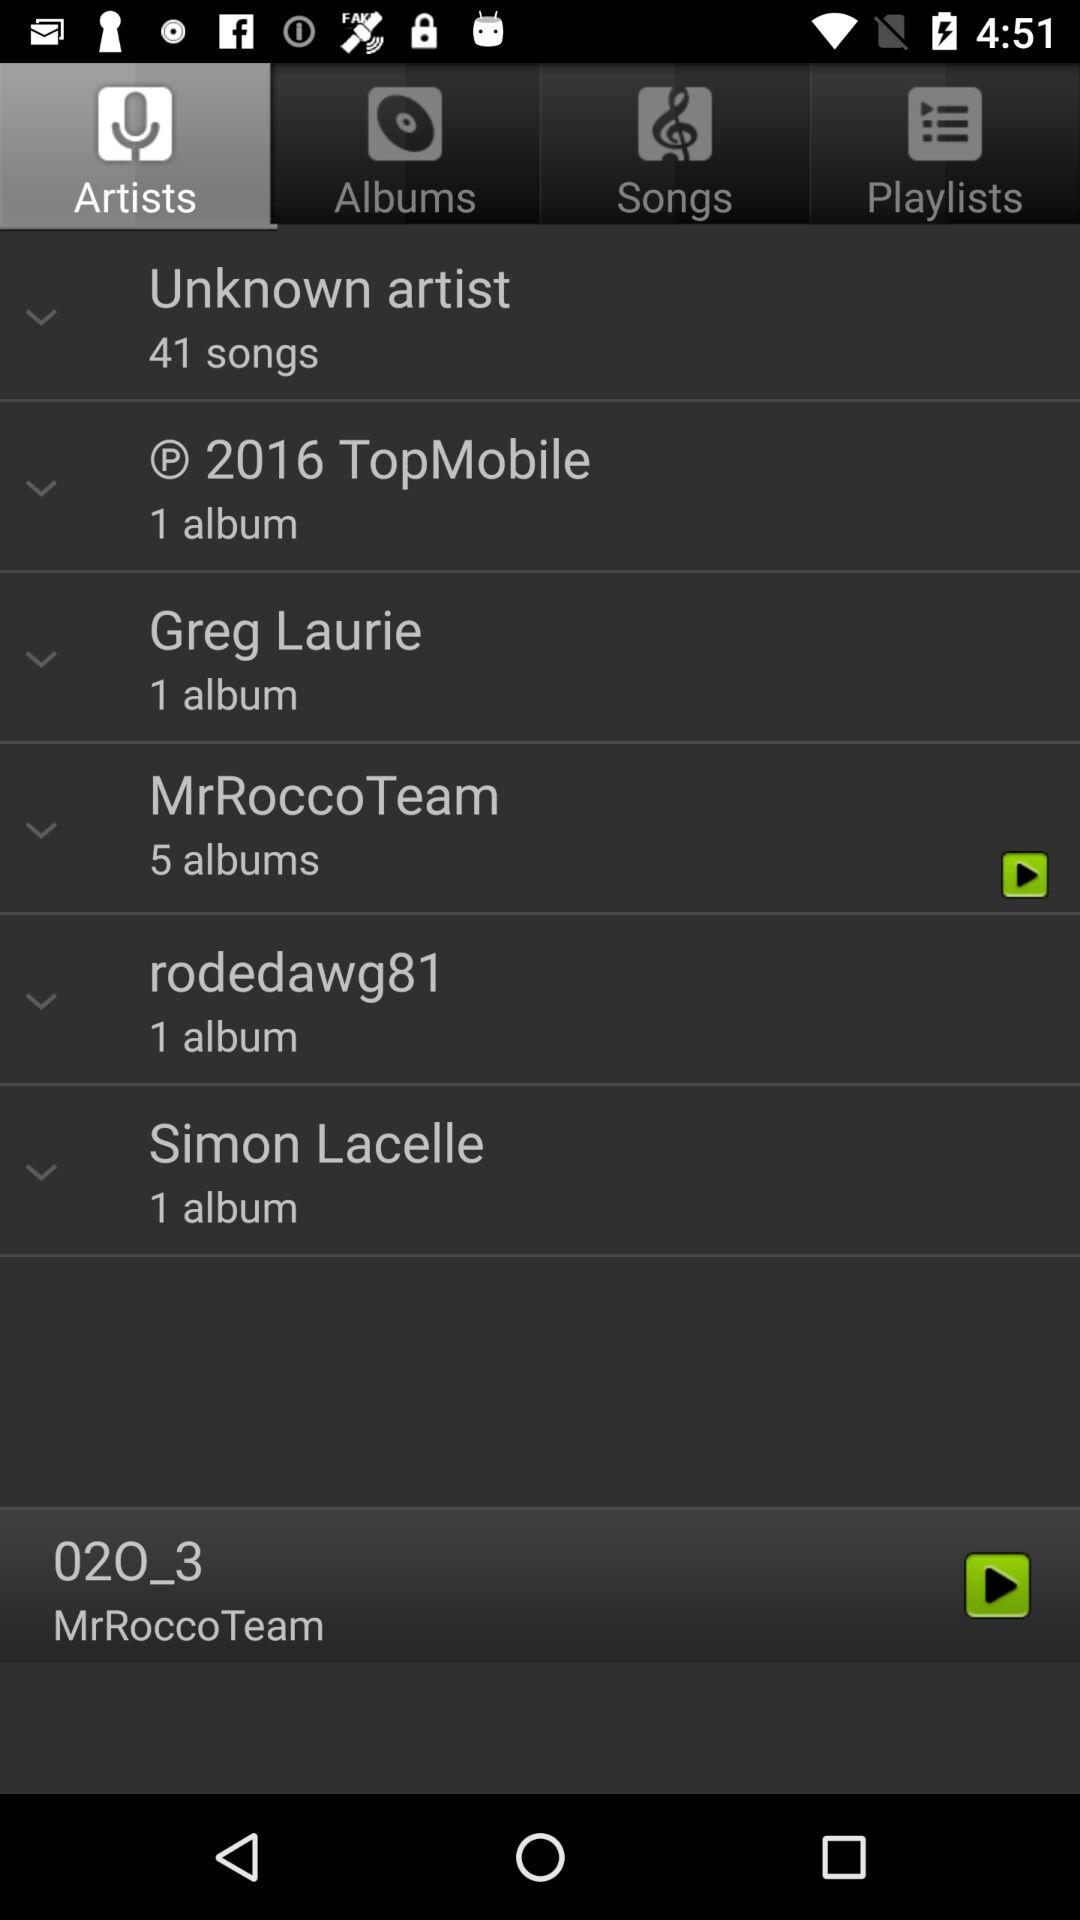When the topmoblle album was released?
When the provided information is insufficient, respond with <no answer>. <no answer> 